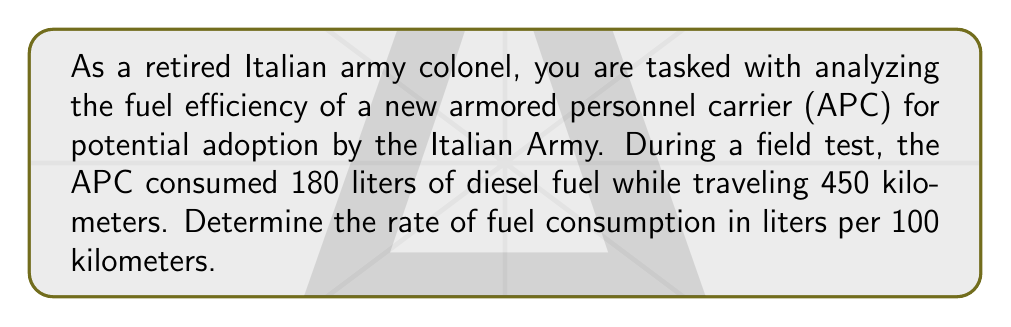Can you solve this math problem? To solve this problem, we need to follow these steps:

1. Identify the given information:
   - Distance traveled: 450 km
   - Fuel consumed: 180 liters

2. Set up the equation for fuel consumption rate:
   $\text{Fuel Consumption Rate} = \frac{\text{Fuel Consumed}}{\text{Distance Traveled}} \times 100$

3. Substitute the values into the equation:
   $$\text{Fuel Consumption Rate} = \frac{180 \text{ liters}}{450 \text{ km}} \times 100$$

4. Simplify the fraction:
   $$\text{Fuel Consumption Rate} = \frac{180}{450} \times 100 = 0.4 \times 100 = 40$$

5. Add the units:
   $$\text{Fuel Consumption Rate} = 40 \text{ liters per 100 km}$$

This result means that the APC consumes 40 liters of diesel fuel for every 100 kilometers traveled.
Answer: The rate of fuel consumption for the armored personnel carrier is 40 liters per 100 kilometers. 